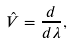Convert formula to latex. <formula><loc_0><loc_0><loc_500><loc_500>\hat { V } = \frac { d } { d \lambda } ,</formula> 